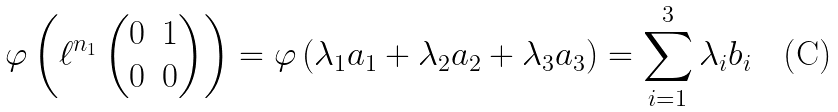Convert formula to latex. <formula><loc_0><loc_0><loc_500><loc_500>\varphi \left ( \ell ^ { n _ { 1 } } \left ( \begin{matrix} 0 & 1 \\ 0 & 0 \end{matrix} \right ) \right ) = \varphi \left ( \lambda _ { 1 } a _ { 1 } + \lambda _ { 2 } a _ { 2 } + \lambda _ { 3 } a _ { 3 } \right ) = \sum _ { i = 1 } ^ { 3 } \lambda _ { i } b _ { i }</formula> 